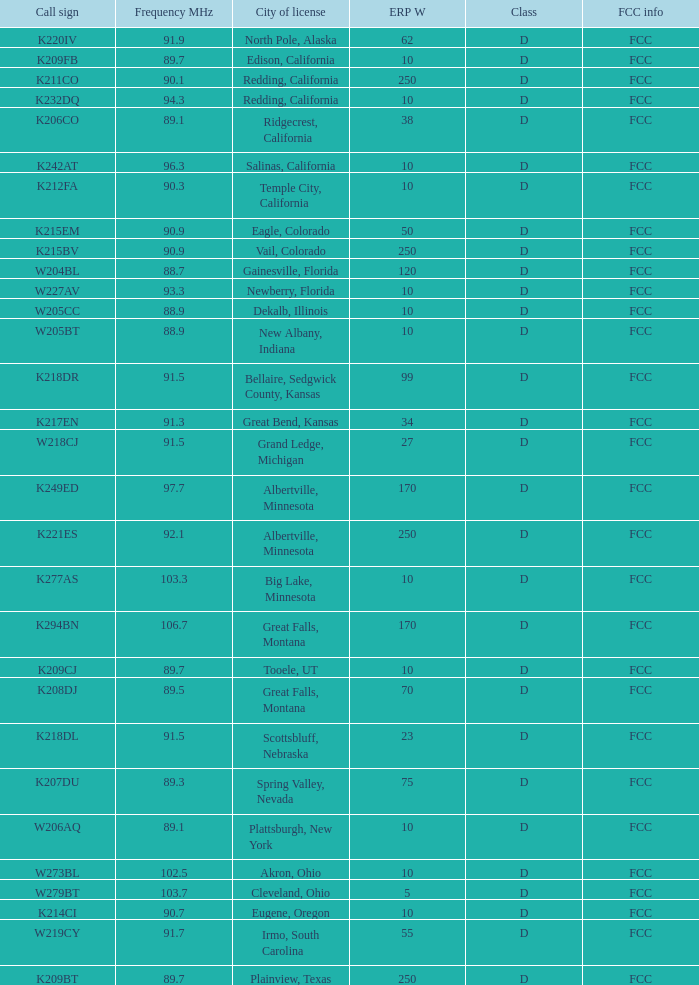What are the fcc specifications for the translator that has a city license in irmo, south carolina? FCC. 